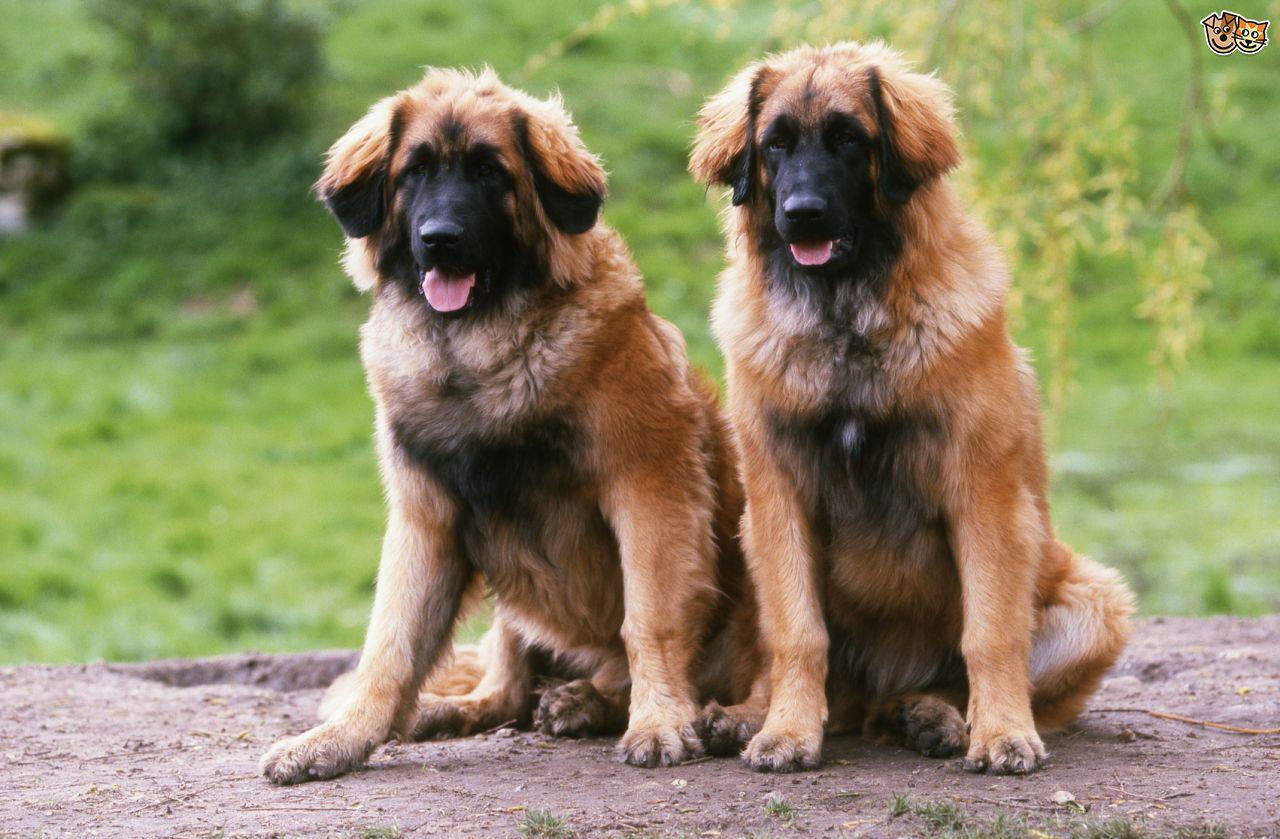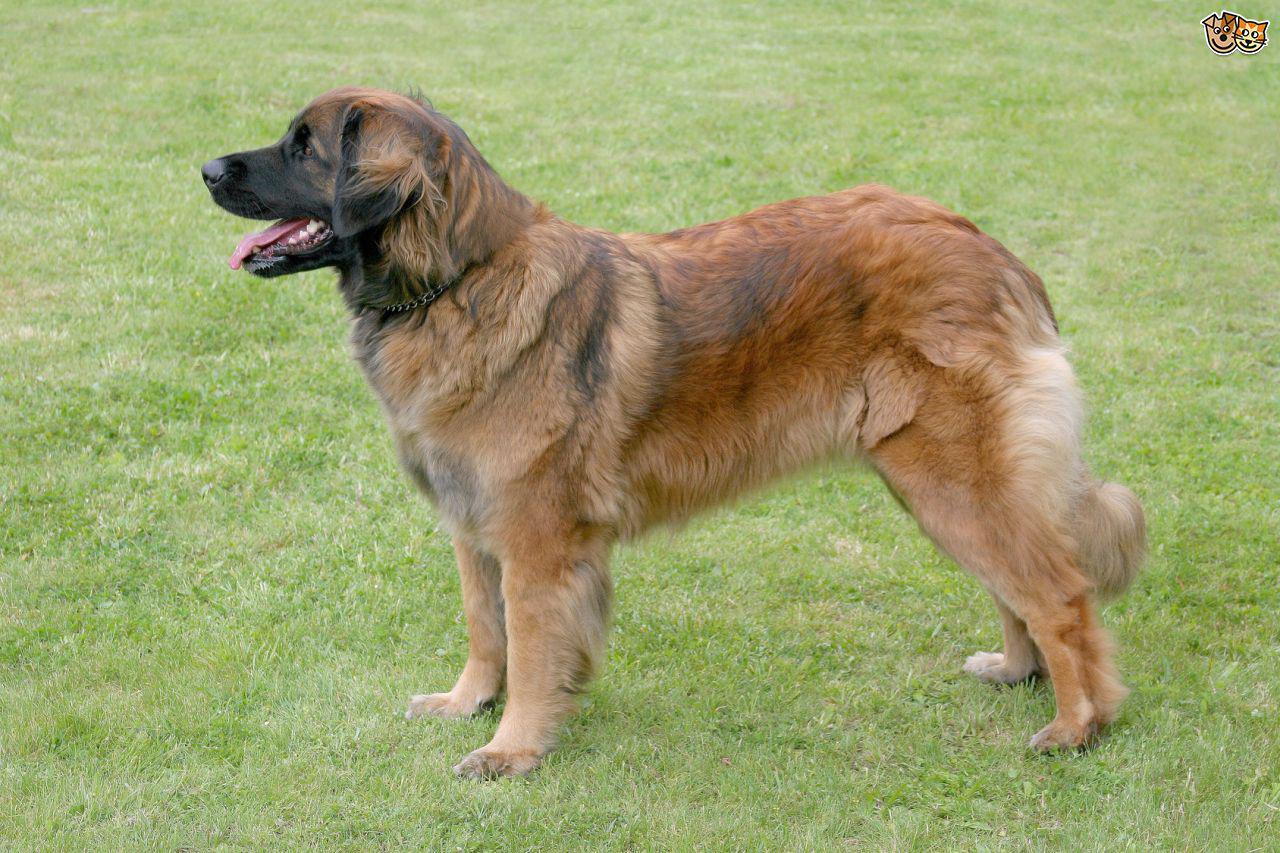The first image is the image on the left, the second image is the image on the right. Assess this claim about the two images: "A person is touching a dog". Correct or not? Answer yes or no. No. 